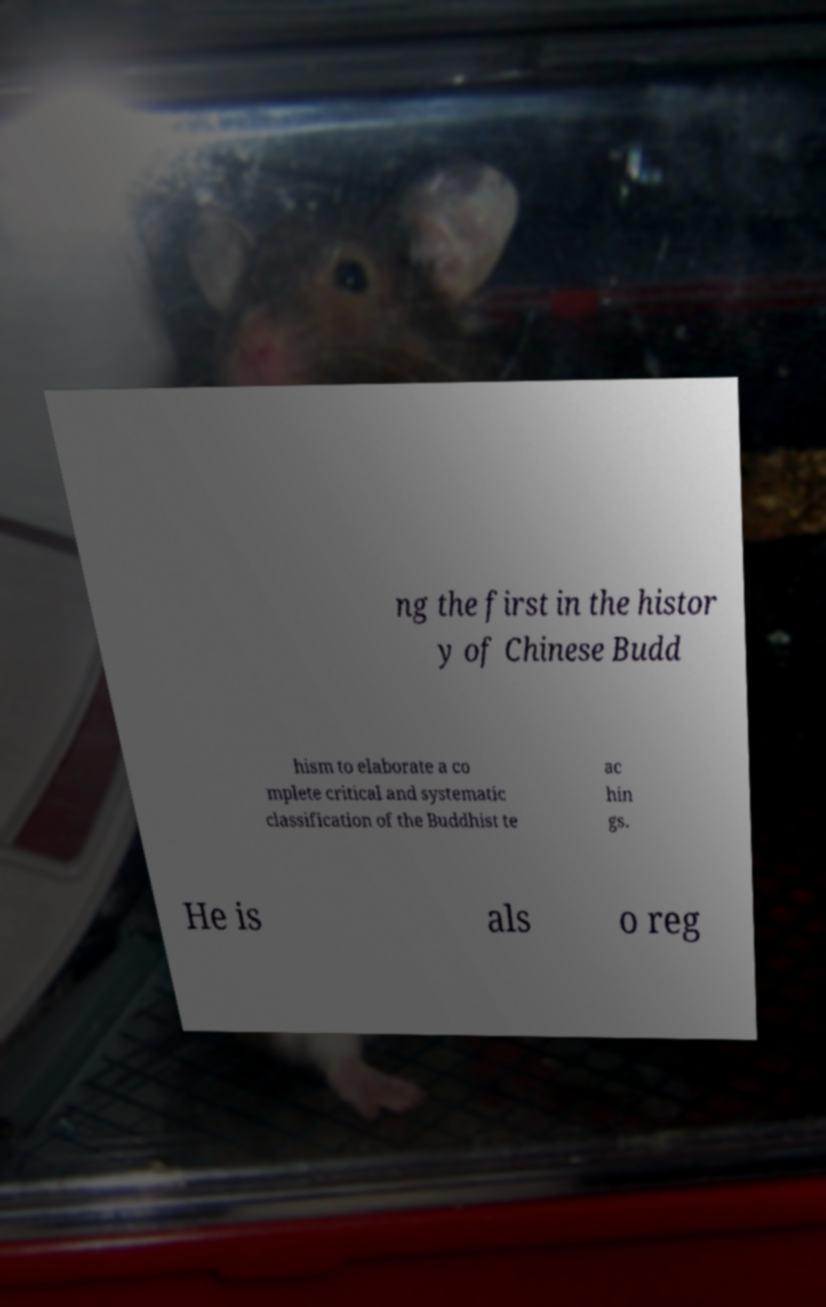For documentation purposes, I need the text within this image transcribed. Could you provide that? ng the first in the histor y of Chinese Budd hism to elaborate a co mplete critical and systematic classification of the Buddhist te ac hin gs. He is als o reg 